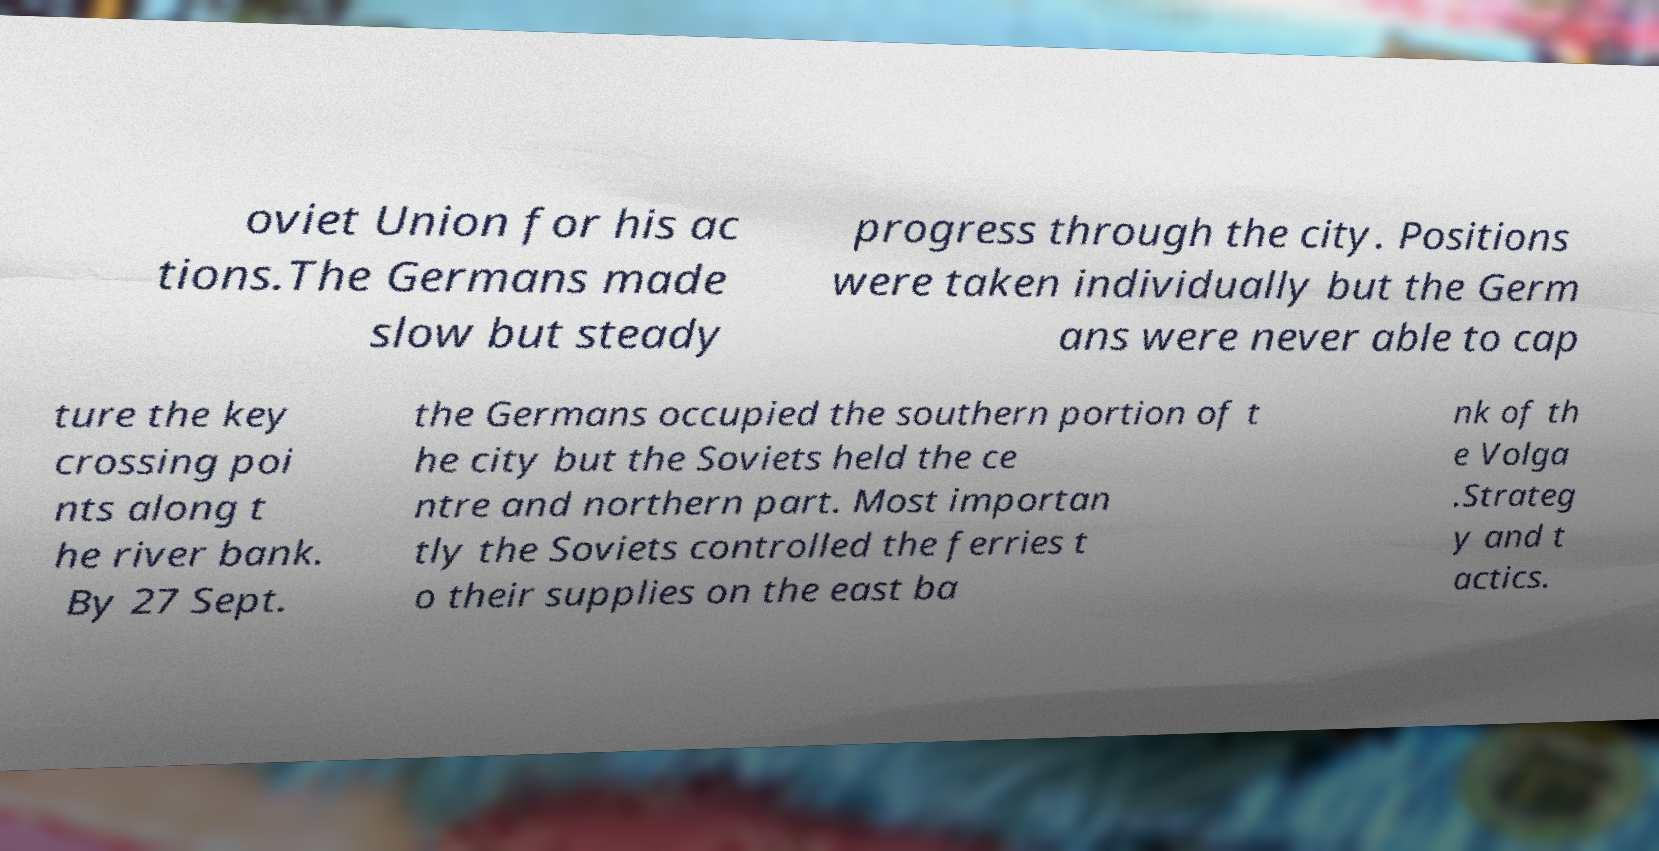Please read and relay the text visible in this image. What does it say? oviet Union for his ac tions.The Germans made slow but steady progress through the city. Positions were taken individually but the Germ ans were never able to cap ture the key crossing poi nts along t he river bank. By 27 Sept. the Germans occupied the southern portion of t he city but the Soviets held the ce ntre and northern part. Most importan tly the Soviets controlled the ferries t o their supplies on the east ba nk of th e Volga .Strateg y and t actics. 